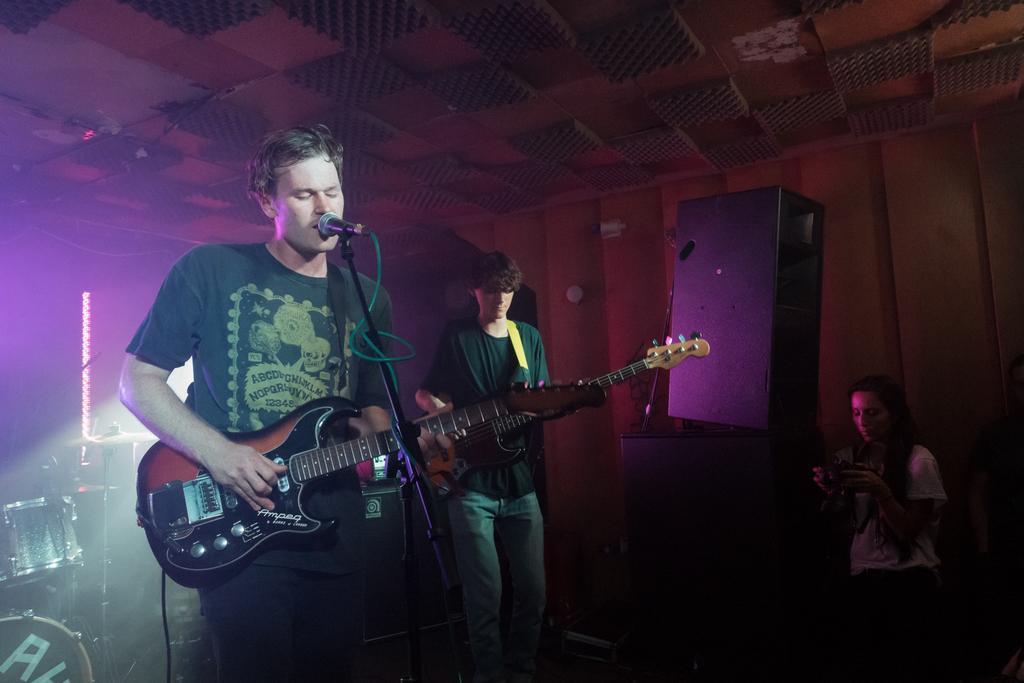Describe this image in one or two sentences. In this picture there is one boy who is playing the guitar and singing in the mice, there is one boy who is standing at the back side of the boy and there are two speakers on the stage, there are two drums behind the boy and one girl who is standing she is recording the songs in her phone. 